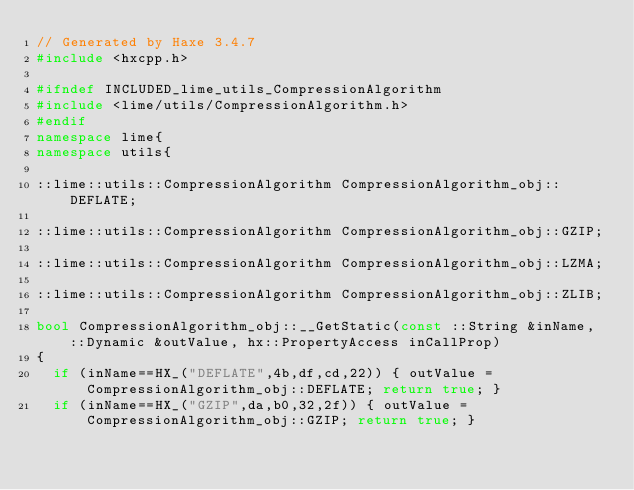Convert code to text. <code><loc_0><loc_0><loc_500><loc_500><_C++_>// Generated by Haxe 3.4.7
#include <hxcpp.h>

#ifndef INCLUDED_lime_utils_CompressionAlgorithm
#include <lime/utils/CompressionAlgorithm.h>
#endif
namespace lime{
namespace utils{

::lime::utils::CompressionAlgorithm CompressionAlgorithm_obj::DEFLATE;

::lime::utils::CompressionAlgorithm CompressionAlgorithm_obj::GZIP;

::lime::utils::CompressionAlgorithm CompressionAlgorithm_obj::LZMA;

::lime::utils::CompressionAlgorithm CompressionAlgorithm_obj::ZLIB;

bool CompressionAlgorithm_obj::__GetStatic(const ::String &inName, ::Dynamic &outValue, hx::PropertyAccess inCallProp)
{
	if (inName==HX_("DEFLATE",4b,df,cd,22)) { outValue = CompressionAlgorithm_obj::DEFLATE; return true; }
	if (inName==HX_("GZIP",da,b0,32,2f)) { outValue = CompressionAlgorithm_obj::GZIP; return true; }</code> 